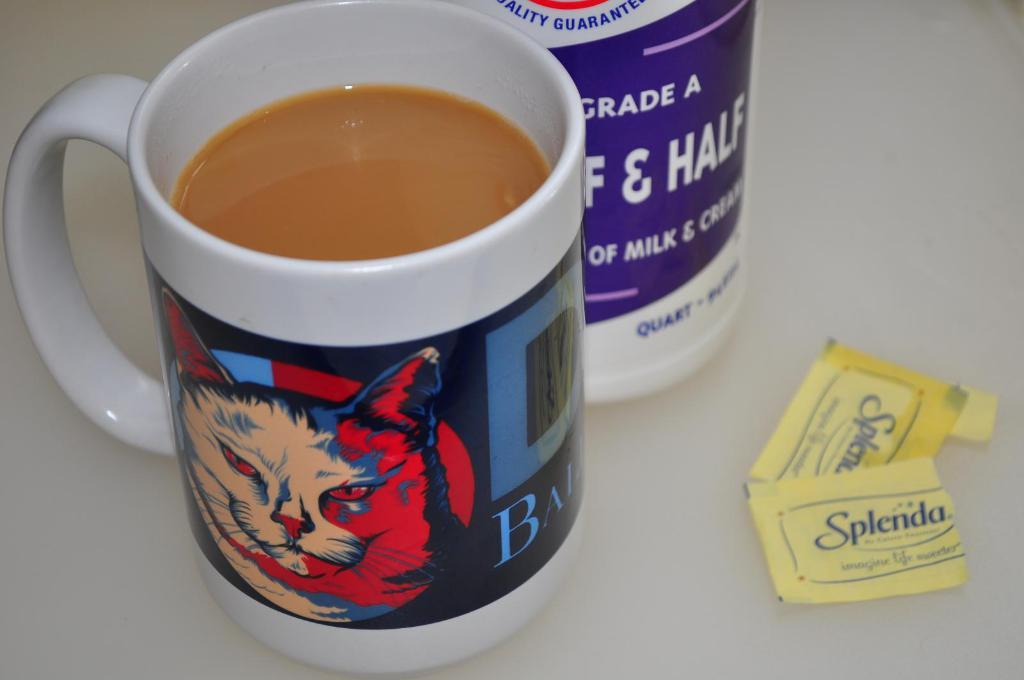Provide a one-sentence caption for the provided image. A full mug of coffee is sitting next to some open packages of Splenda. 